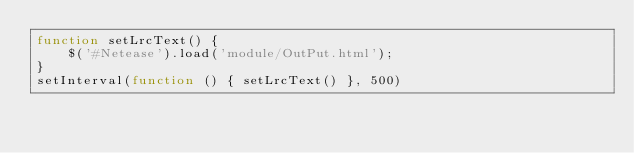Convert code to text. <code><loc_0><loc_0><loc_500><loc_500><_JavaScript_>function setLrcText() {
    $('#Netease').load('module/OutPut.html');
}
setInterval(function () { setLrcText() }, 500)
</code> 